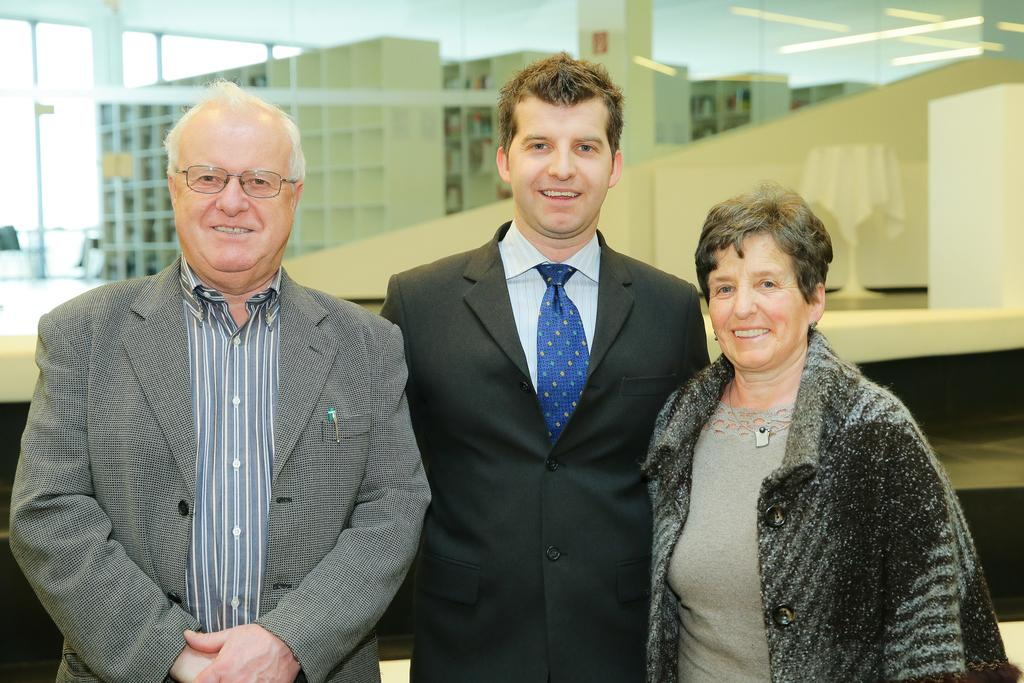Who or what is present in the image? There are people and buildings in the image. Can you describe the surroundings or setting in the image? There is a reflection of lights on the glass in the image. What type of wood can be seen in the image? There is no wood present in the image; it features people, buildings, and a reflection of lights on the glass. 